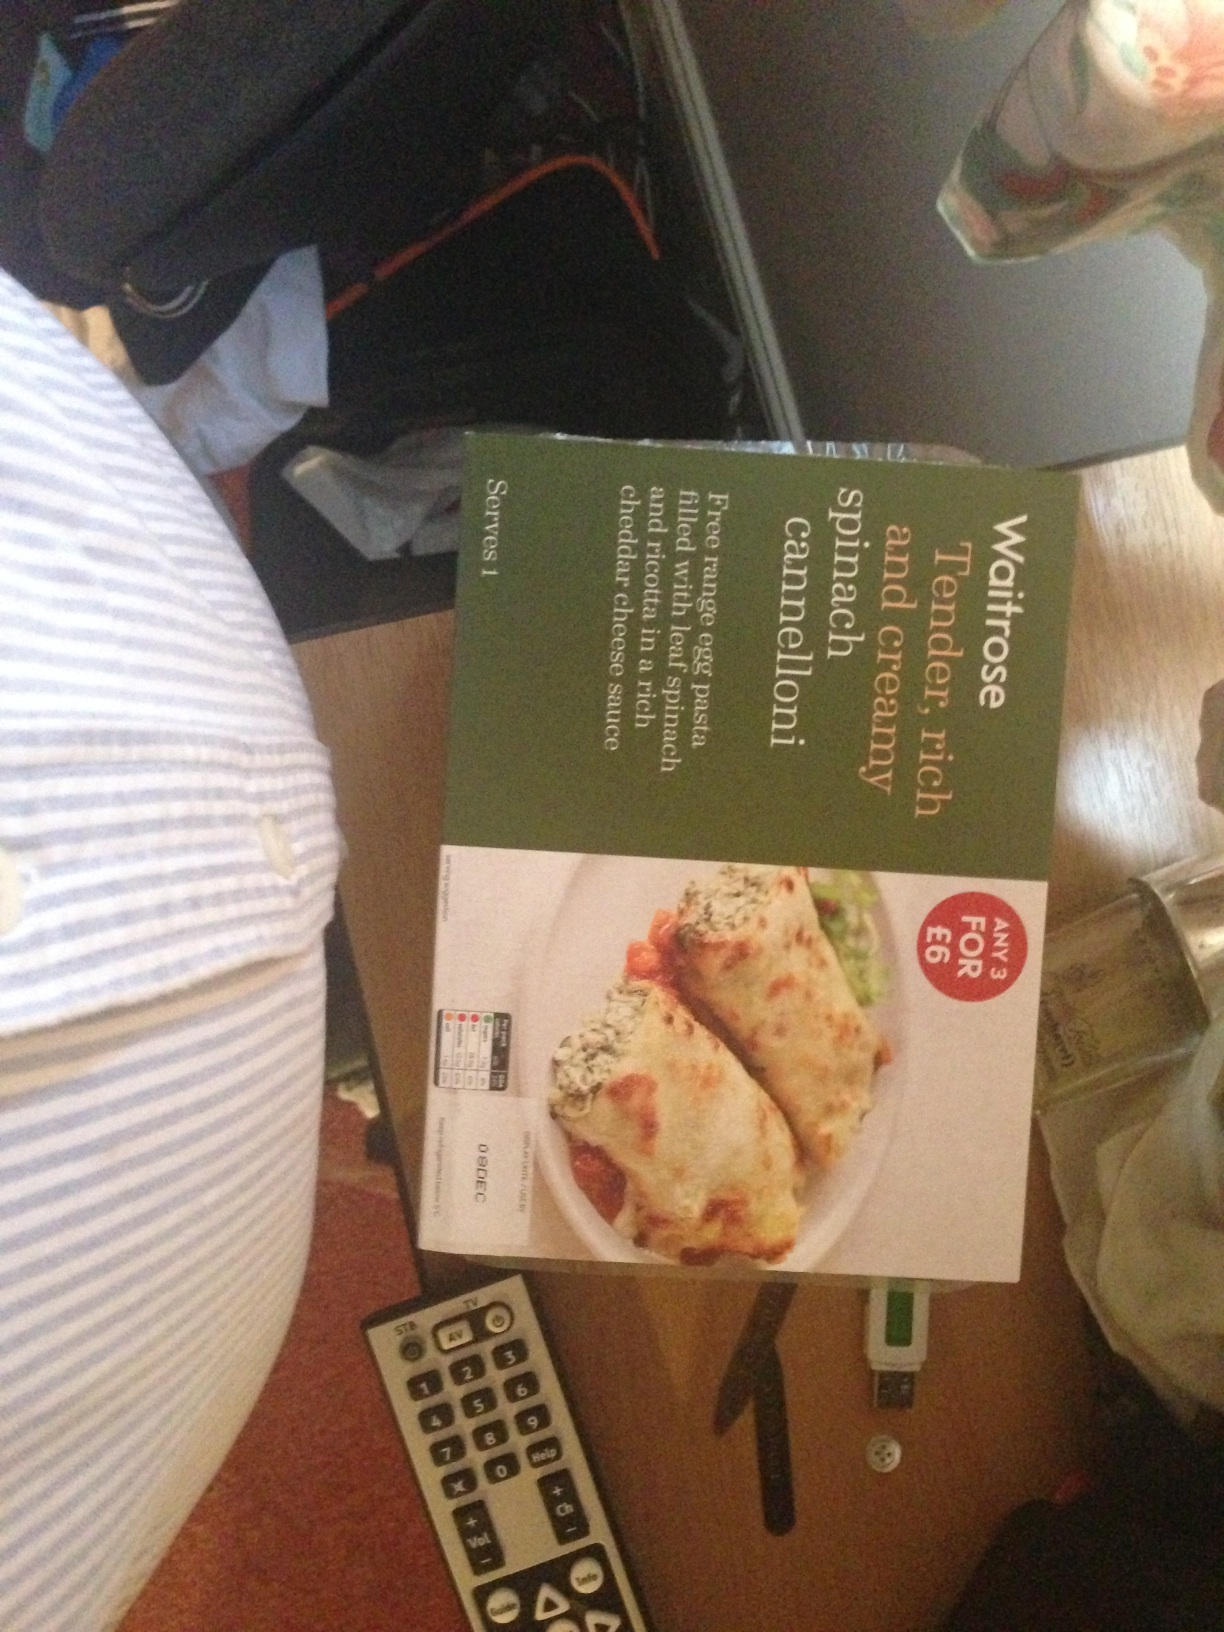I just would like to know which ready meal this is. from Vizwiz spinach cannelloni 